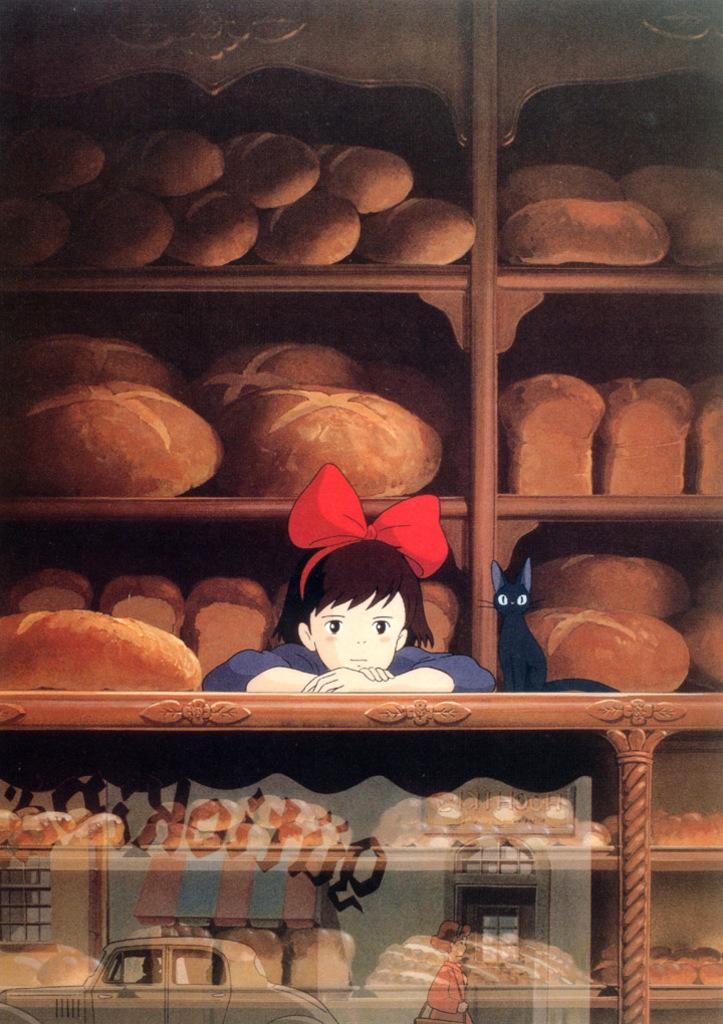What type of characters are present in the image? There is a cartoon girl and a cartoon cat in the image. How are the girl and cat different in appearance? The girl and cat are in different colors. What can be seen in the background of the image? There are brown color objects on a rack in the background. What is located in the front of the image? There is a car and a person in the front of the image. What type of bell can be heard ringing in the image? There is no bell present in the image, and therefore no sound can be heard. How many arms does the girl have in the image? The image is a cartoon, and cartoon characters typically have two arms, but we cannot definitively determine the number of arms from the image alone. 